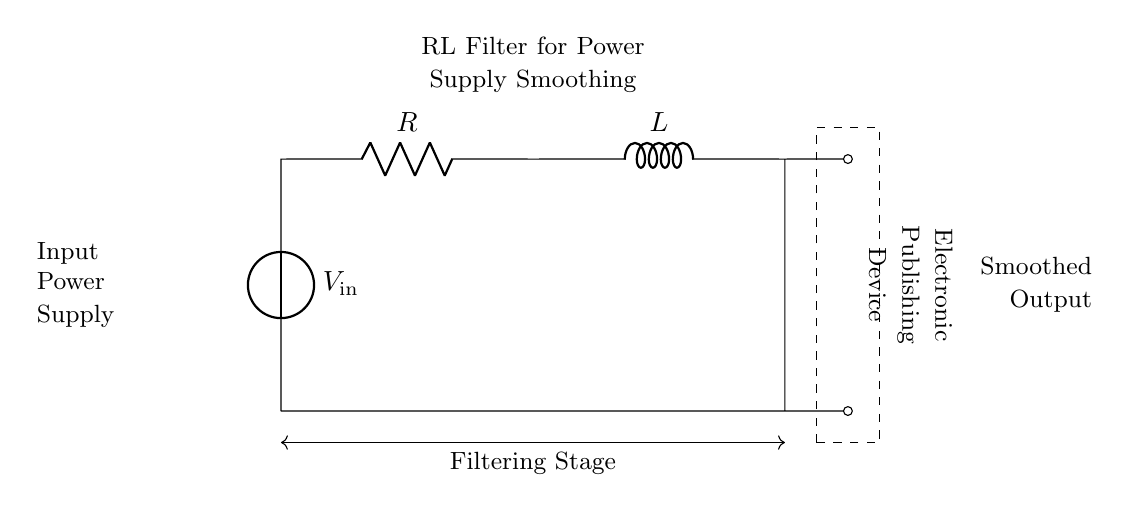What type of filter is shown in the circuit diagram? The circuit is an RL filter, which consists of a resistor and an inductor used to smooth out voltage fluctuations.
Answer: RL filter What is the purpose of the inductor in this circuit? The inductor stores energy in a magnetic field when current passes through it, allowing it to resist changes in current, thus smoothing the output voltage.
Answer: Smooth output What does the symbol V in the circuit represent? The symbol V represents the input voltage source, which provides the electrical energy needed for the circuit to function.
Answer: Input voltage What is the essential role of the resistor in this RL filter circuit? The resistor limits current flow and dissipates energy as heat, working together with the inductor to reduce voltage fluctuations.
Answer: Current limiting How does the circuit output compare to the input? The output voltage is smoother and less fluctuating compared to the input voltage due to the filtering effects of the RL circuit.
Answer: Smoother voltage What happens to the current in the circuit during sudden changes in input voltage? During sudden changes, the inductor will oppose the change in current, causing the circuit to respond more slowly compared to how quickly the input changes.
Answer: Slower response What is the load indicated by the dashed rectangle in the circuit? The dashed rectangle represents the electronic publishing device that utilizes the smoothed output voltage from the RL filter.
Answer: Electronic publishing device 